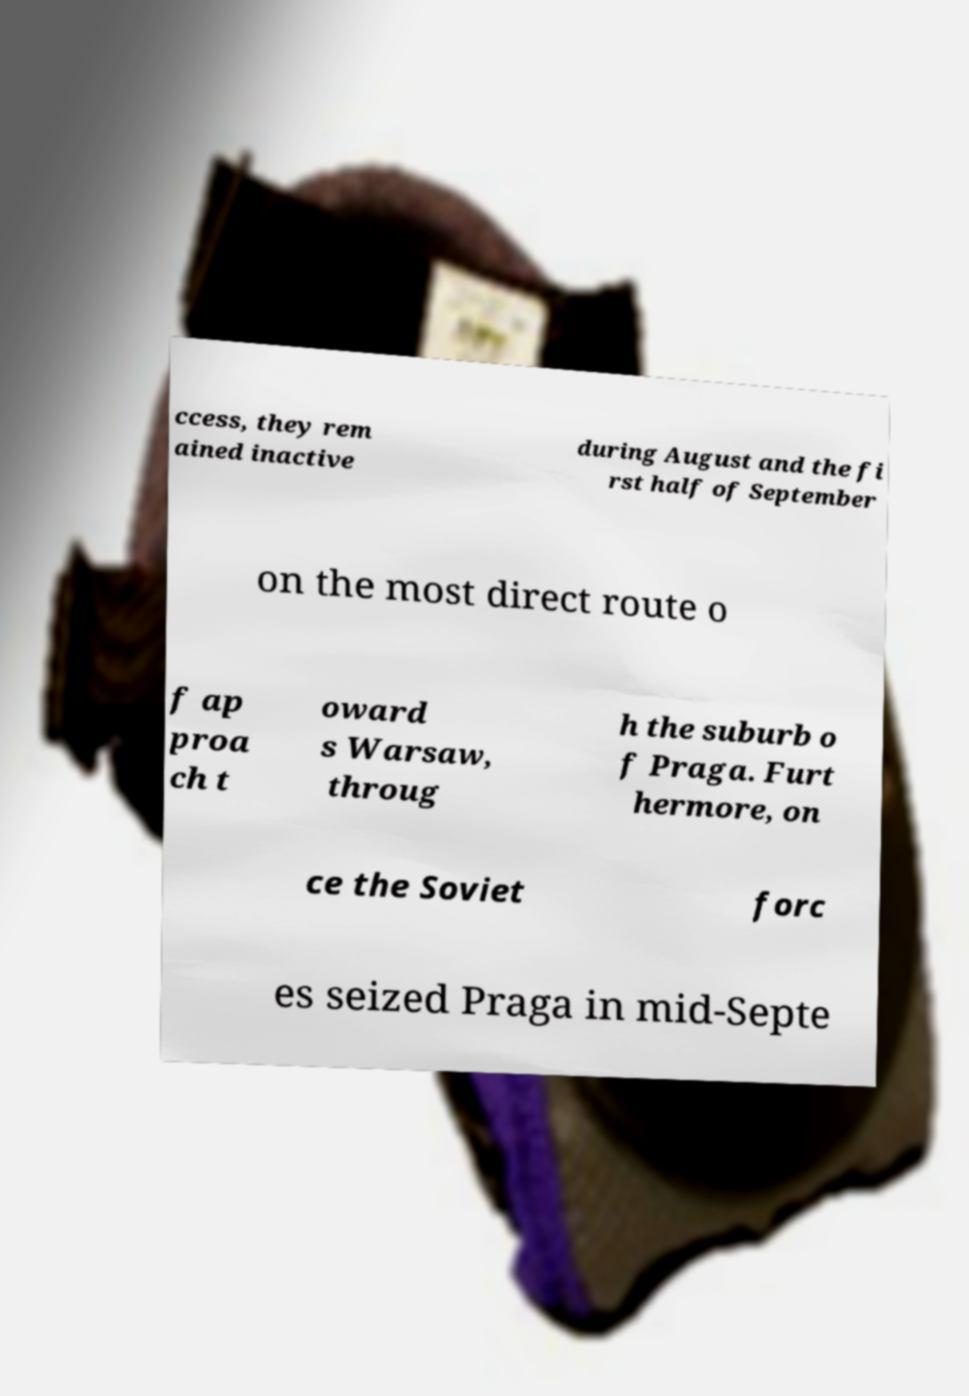Can you read and provide the text displayed in the image?This photo seems to have some interesting text. Can you extract and type it out for me? ccess, they rem ained inactive during August and the fi rst half of September on the most direct route o f ap proa ch t oward s Warsaw, throug h the suburb o f Praga. Furt hermore, on ce the Soviet forc es seized Praga in mid-Septe 